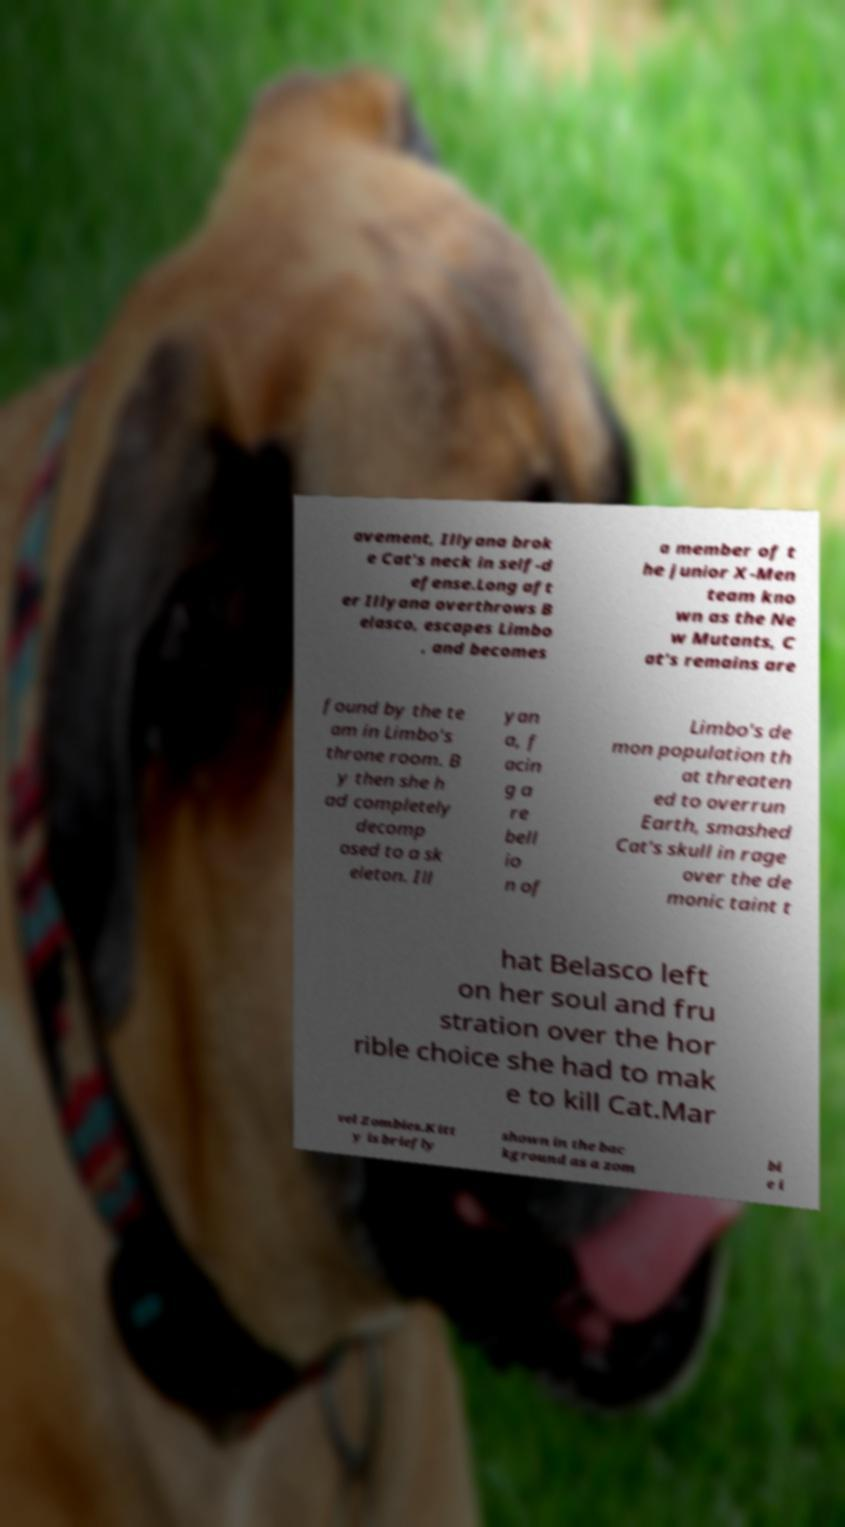Could you assist in decoding the text presented in this image and type it out clearly? avement, Illyana brok e Cat's neck in self-d efense.Long aft er Illyana overthrows B elasco, escapes Limbo , and becomes a member of t he junior X-Men team kno wn as the Ne w Mutants, C at's remains are found by the te am in Limbo's throne room. B y then she h ad completely decomp osed to a sk eleton. Ill yan a, f acin g a re bell io n of Limbo's de mon population th at threaten ed to overrun Earth, smashed Cat's skull in rage over the de monic taint t hat Belasco left on her soul and fru stration over the hor rible choice she had to mak e to kill Cat.Mar vel Zombies.Kitt y is briefly shown in the bac kground as a zom bi e i 